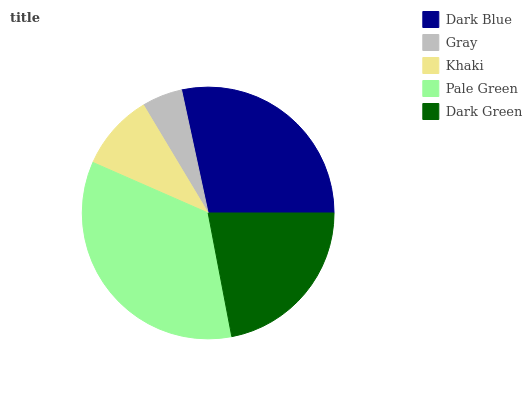Is Gray the minimum?
Answer yes or no. Yes. Is Pale Green the maximum?
Answer yes or no. Yes. Is Khaki the minimum?
Answer yes or no. No. Is Khaki the maximum?
Answer yes or no. No. Is Khaki greater than Gray?
Answer yes or no. Yes. Is Gray less than Khaki?
Answer yes or no. Yes. Is Gray greater than Khaki?
Answer yes or no. No. Is Khaki less than Gray?
Answer yes or no. No. Is Dark Green the high median?
Answer yes or no. Yes. Is Dark Green the low median?
Answer yes or no. Yes. Is Dark Blue the high median?
Answer yes or no. No. Is Pale Green the low median?
Answer yes or no. No. 